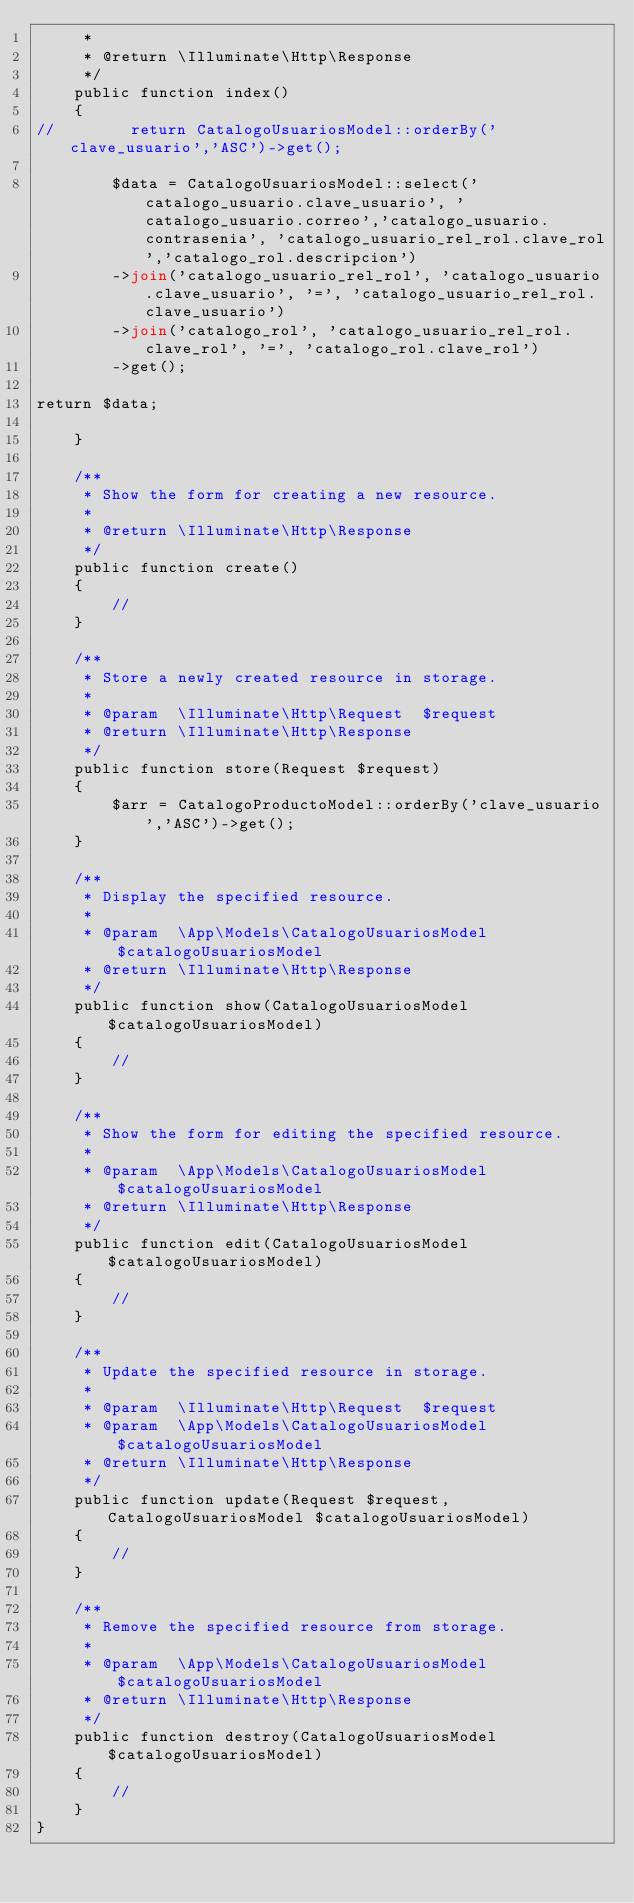Convert code to text. <code><loc_0><loc_0><loc_500><loc_500><_PHP_>     *
     * @return \Illuminate\Http\Response
     */
    public function index()
    {
//        return CatalogoUsuariosModel::orderBy('clave_usuario','ASC')->get();
    
        $data = CatalogoUsuariosModel::select('catalogo_usuario.clave_usuario', 'catalogo_usuario.correo','catalogo_usuario.contrasenia', 'catalogo_usuario_rel_rol.clave_rol','catalogo_rol.descripcion')
        ->join('catalogo_usuario_rel_rol', 'catalogo_usuario.clave_usuario', '=', 'catalogo_usuario_rel_rol.clave_usuario')
        ->join('catalogo_rol', 'catalogo_usuario_rel_rol.clave_rol', '=', 'catalogo_rol.clave_rol')
        ->get();

return $data;

    }

    /**
     * Show the form for creating a new resource.
     *
     * @return \Illuminate\Http\Response
     */
    public function create()
    {
        //
    }

    /**
     * Store a newly created resource in storage.
     *
     * @param  \Illuminate\Http\Request  $request
     * @return \Illuminate\Http\Response
     */
    public function store(Request $request)
    {
        $arr = CatalogoProductoModel::orderBy('clave_usuario','ASC')->get();    
    }

    /**
     * Display the specified resource.
     *
     * @param  \App\Models\CatalogoUsuariosModel  $catalogoUsuariosModel
     * @return \Illuminate\Http\Response
     */
    public function show(CatalogoUsuariosModel $catalogoUsuariosModel)
    {
        //
    }

    /**
     * Show the form for editing the specified resource.
     *
     * @param  \App\Models\CatalogoUsuariosModel  $catalogoUsuariosModel
     * @return \Illuminate\Http\Response
     */
    public function edit(CatalogoUsuariosModel $catalogoUsuariosModel)
    {
        //
    }

    /**
     * Update the specified resource in storage.
     *
     * @param  \Illuminate\Http\Request  $request
     * @param  \App\Models\CatalogoUsuariosModel  $catalogoUsuariosModel
     * @return \Illuminate\Http\Response
     */
    public function update(Request $request, CatalogoUsuariosModel $catalogoUsuariosModel)
    {
        //
    }

    /**
     * Remove the specified resource from storage.
     *
     * @param  \App\Models\CatalogoUsuariosModel  $catalogoUsuariosModel
     * @return \Illuminate\Http\Response
     */
    public function destroy(CatalogoUsuariosModel $catalogoUsuariosModel)
    {
        //
    }
}
</code> 